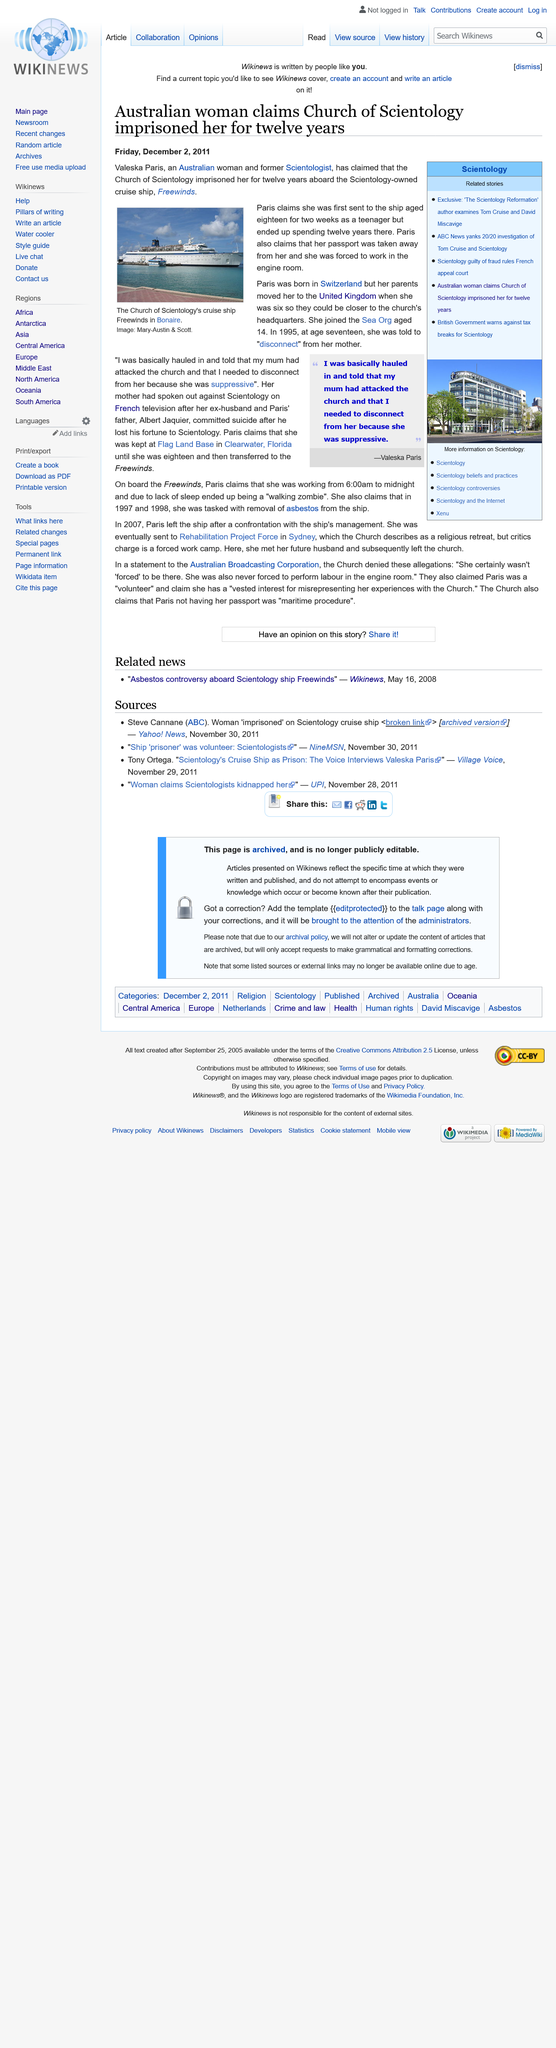Mention a couple of crucial points in this snapshot. Valeska Paris was 14 years old when she joined the Sea Org. Valueska Paris was born in Switzerland. The Church of Scientology is mentioned in this article. 